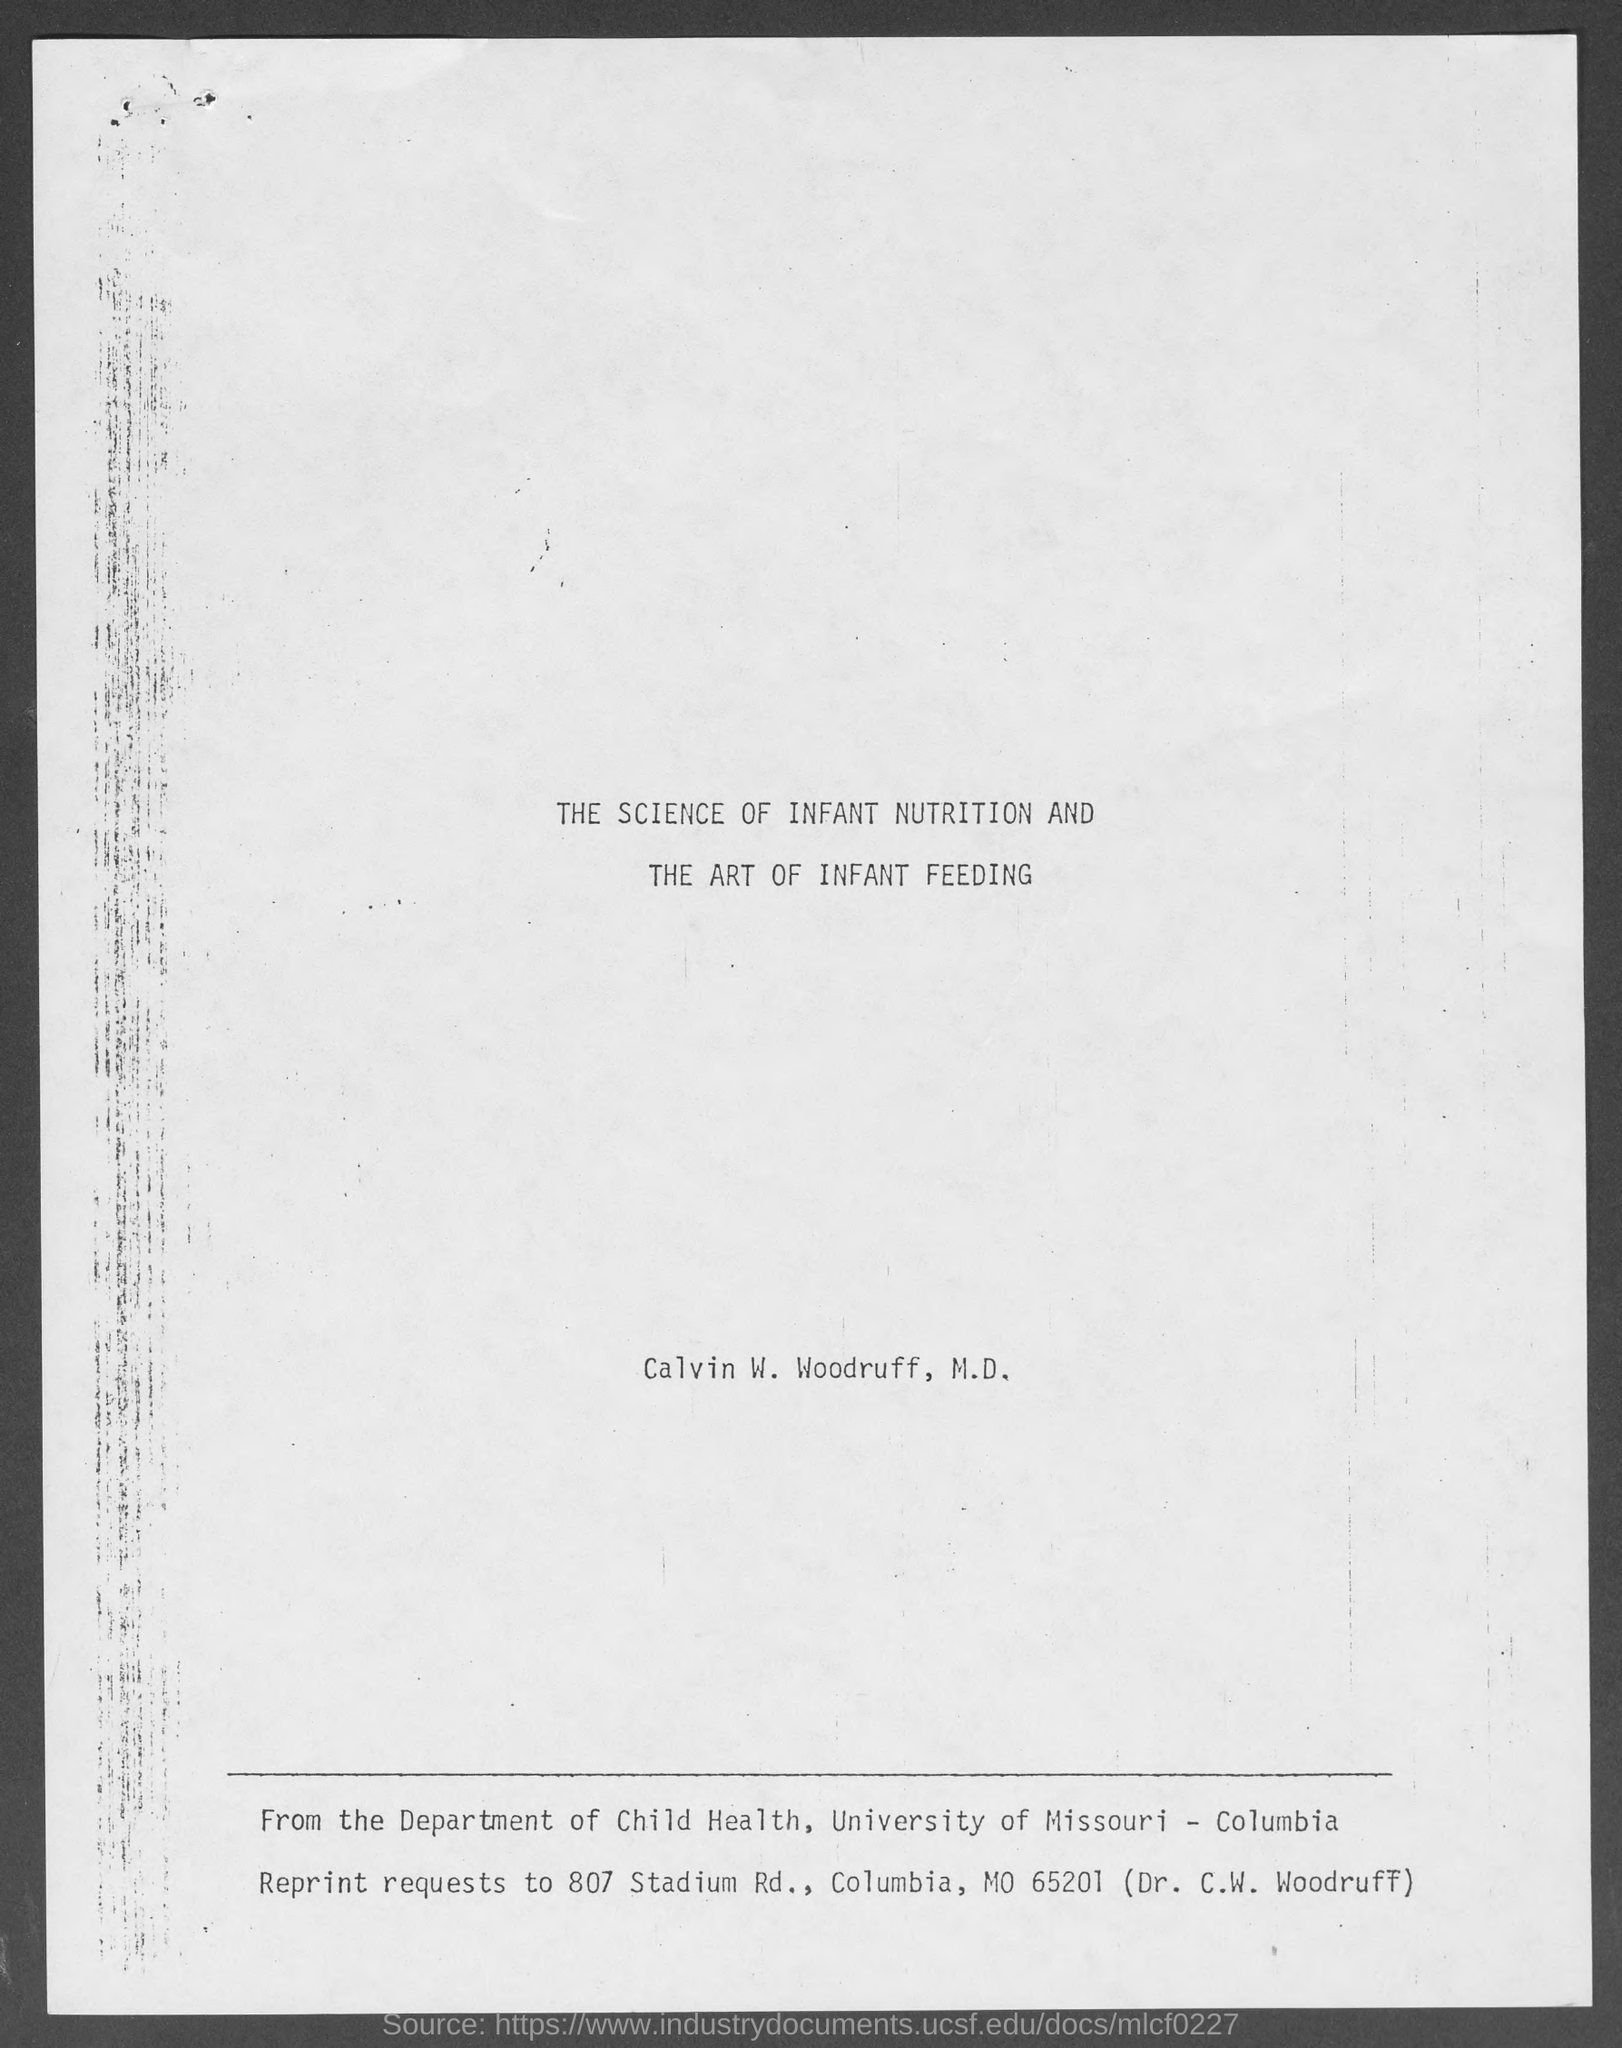Mention a couple of crucial points in this snapshot. The name of the person written on the document is Calvin W. Woodruff, M.D. The department is the Department of Child Health. 